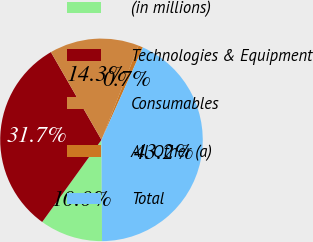Convert chart to OTSL. <chart><loc_0><loc_0><loc_500><loc_500><pie_chart><fcel>(in millions)<fcel>Technologies & Equipment<fcel>Consumables<fcel>All Other (a)<fcel>Total<nl><fcel>10.04%<fcel>31.73%<fcel>14.28%<fcel>0.74%<fcel>43.21%<nl></chart> 